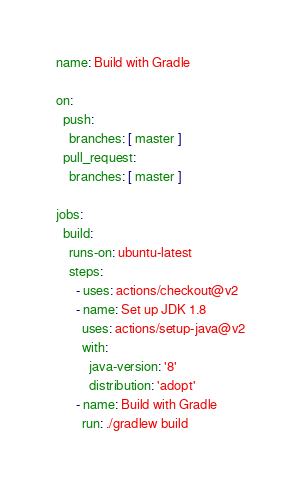Convert code to text. <code><loc_0><loc_0><loc_500><loc_500><_YAML_>name: Build with Gradle

on:
  push:
    branches: [ master ]
  pull_request:
    branches: [ master ]

jobs:
  build:
    runs-on: ubuntu-latest
    steps:
      - uses: actions/checkout@v2
      - name: Set up JDK 1.8
        uses: actions/setup-java@v2
        with:
          java-version: '8'
          distribution: 'adopt'
      - name: Build with Gradle
        run: ./gradlew build
</code> 